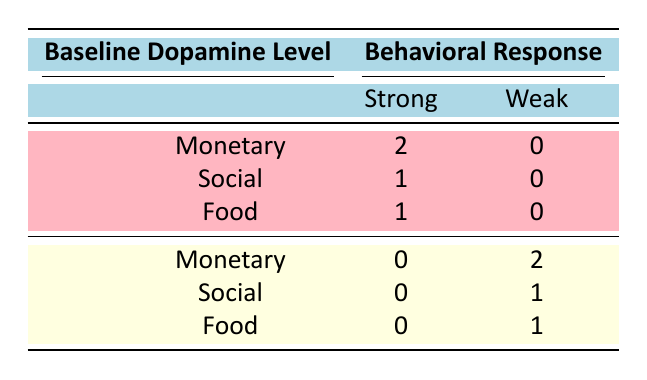What is the total number of individuals with a high baseline dopamine level who had a strong behavioral response? There are 3 individuals with a high baseline dopamine level, and all of them reported a strong behavioral response. The reward types were monetary (2), social (1), and food (1). Since all responses categorized as strong are from the high dopamine group, the total is 3.
Answer: 3 How many individuals with low baseline dopamine levels experienced a weak behavioral response? There are 3 individuals with low baseline dopamine levels, with 2 reporting a weak behavioral response for monetary rewards and 1 for social rewards. Therefore, the total number of individuals with a weak response is 3.
Answer: 3 Is it true that all individuals with a high baseline dopamine level had a strong behavioral response? There are 3 individuals with a high baseline dopamine level, and all reported a strong behavioral response for monetary, social, and food rewards, making the statement true.
Answer: Yes What is the difference in the number of strong responses between high and low baseline dopamine groups for monetary rewards? For the high baseline dopamine group, there are 2 strong responses, while for the low group, there are 0 strong responses. The difference is calculated as 2 - 0 = 2.
Answer: 2 How many total responses were recorded for individuals with low baseline dopamine levels? There are 3 individuals with low baseline dopamine levels, and the breakdown of their responses shows that 2 experienced weak responses for monetary rewards, 1 experienced a weak response for social rewards, and 1 experienced a moderate response for food. So, the total count comes to 4 responses of various types (2 weak, 1 weak, and 1 moderate).
Answer: 4 What percentage of individuals with a high baseline dopamine level showed a strong engagement level? All 3 individuals with high baseline dopamine level showed strong engagement and strong behavioral response. To calculate the percentage, we use the formula (Number of Strong Responses / Total High Responses) * 100, which is (3 / 3) * 100 = 100%.
Answer: 100% How does the engagement level of the low baseline dopamine group compare to that of the high group overall? For the high dopamine group, all individuals had high engagement levels. In contrast, the low dopamine group had 2 with low engagement (monetary) and 1 with moderate engagement (food), resulting in lower engagement levels overall. Thus, the high group shows consistent high engagement versus a mix of low and moderate in the low group.
Answer: High versus low What types of rewards resulted in weak responses among individuals with low baseline dopamine levels? The table indicates that individuals with low baseline dopamine levels showed weak responses for monetary (2 individuals) and social rewards (1 individual), thus identifying monetary and social as the types leading to weak responses.
Answer: Monetary and social 